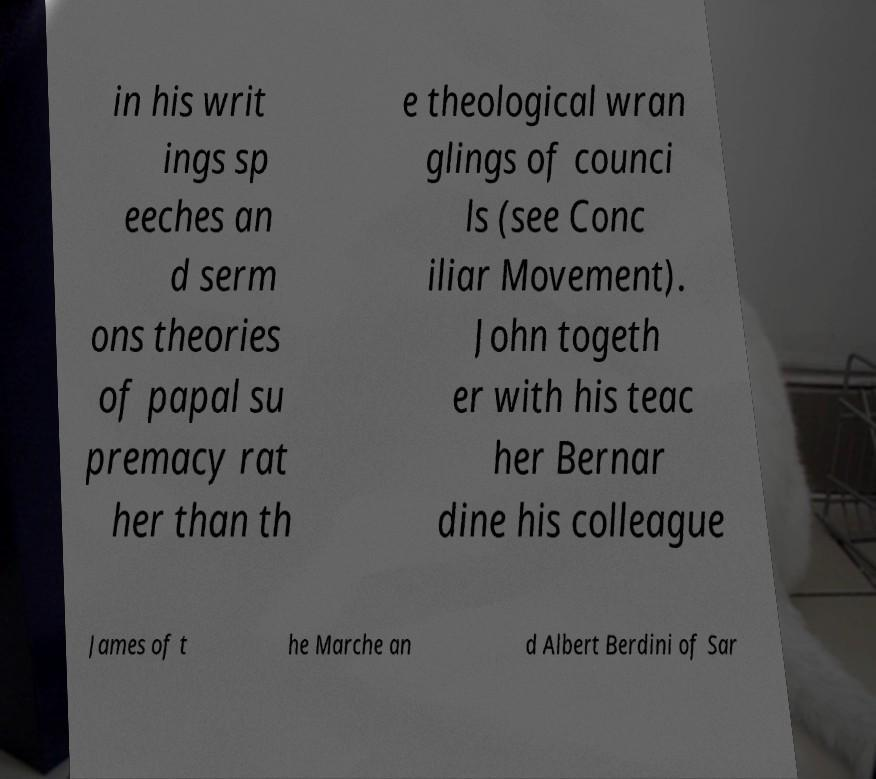Could you assist in decoding the text presented in this image and type it out clearly? in his writ ings sp eeches an d serm ons theories of papal su premacy rat her than th e theological wran glings of counci ls (see Conc iliar Movement). John togeth er with his teac her Bernar dine his colleague James of t he Marche an d Albert Berdini of Sar 